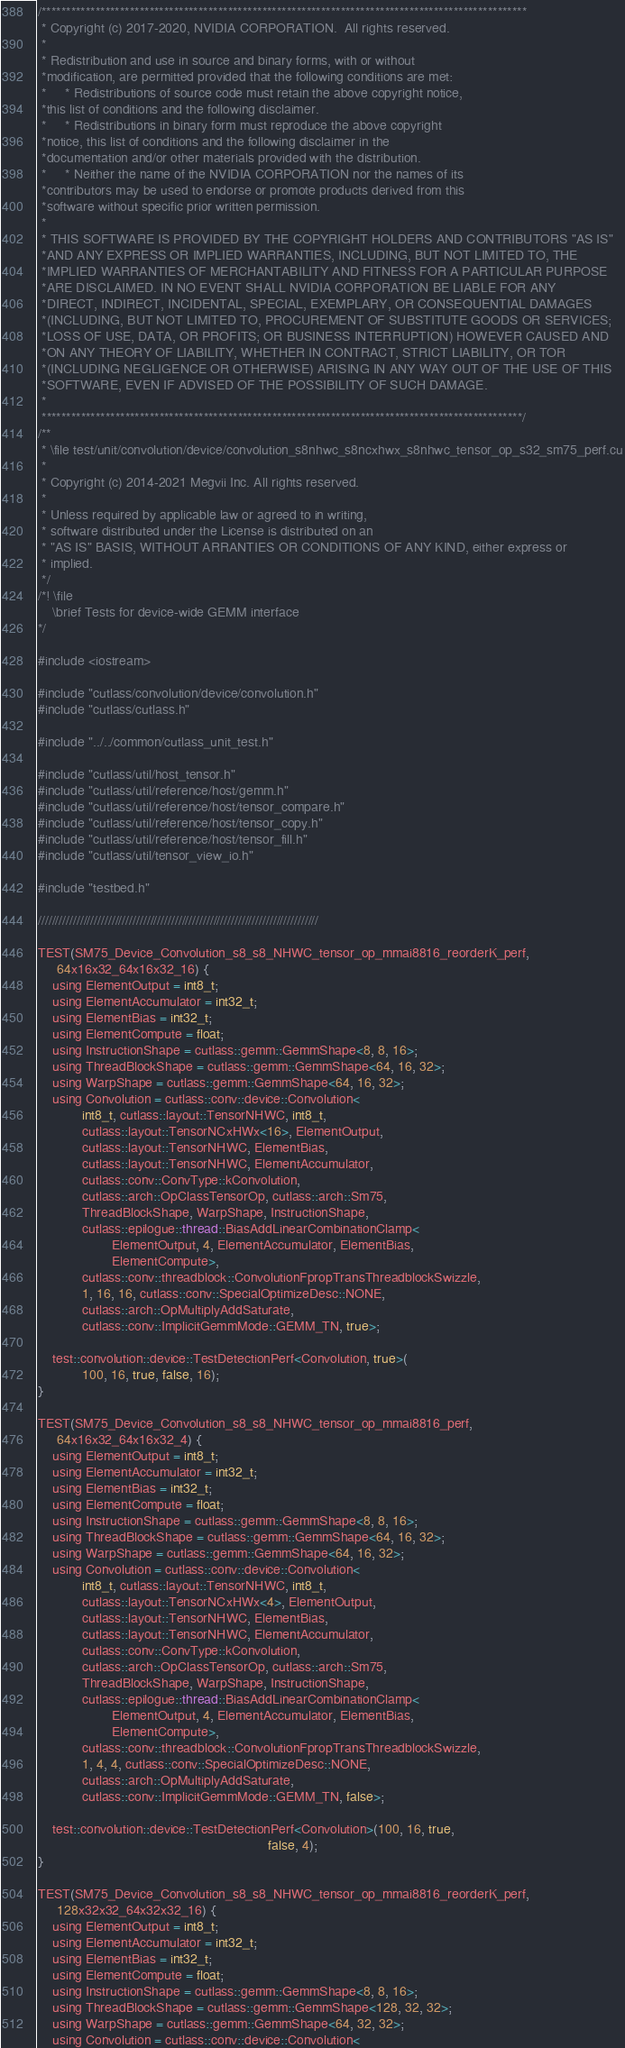Convert code to text. <code><loc_0><loc_0><loc_500><loc_500><_Cuda_>/***************************************************************************************************
 * Copyright (c) 2017-2020, NVIDIA CORPORATION.  All rights reserved.
 *
 * Redistribution and use in source and binary forms, with or without
 *modification, are permitted provided that the following conditions are met:
 *     * Redistributions of source code must retain the above copyright notice,
 *this list of conditions and the following disclaimer.
 *     * Redistributions in binary form must reproduce the above copyright
 *notice, this list of conditions and the following disclaimer in the
 *documentation and/or other materials provided with the distribution.
 *     * Neither the name of the NVIDIA CORPORATION nor the names of its
 *contributors may be used to endorse or promote products derived from this
 *software without specific prior written permission.
 *
 * THIS SOFTWARE IS PROVIDED BY THE COPYRIGHT HOLDERS AND CONTRIBUTORS "AS IS"
 *AND ANY EXPRESS OR IMPLIED WARRANTIES, INCLUDING, BUT NOT LIMITED TO, THE
 *IMPLIED WARRANTIES OF MERCHANTABILITY AND FITNESS FOR A PARTICULAR PURPOSE
 *ARE DISCLAIMED. IN NO EVENT SHALL NVIDIA CORPORATION BE LIABLE FOR ANY
 *DIRECT, INDIRECT, INCIDENTAL, SPECIAL, EXEMPLARY, OR CONSEQUENTIAL DAMAGES
 *(INCLUDING, BUT NOT LIMITED TO, PROCUREMENT OF SUBSTITUTE GOODS OR SERVICES;
 *LOSS OF USE, DATA, OR PROFITS; OR BUSINESS INTERRUPTION) HOWEVER CAUSED AND
 *ON ANY THEORY OF LIABILITY, WHETHER IN CONTRACT, STRICT LIABILITY, OR TOR
 *(INCLUDING NEGLIGENCE OR OTHERWISE) ARISING IN ANY WAY OUT OF THE USE OF THIS
 *SOFTWARE, EVEN IF ADVISED OF THE POSSIBILITY OF SUCH DAMAGE.
 *
 **************************************************************************************************/
/**
 * \file test/unit/convolution/device/convolution_s8nhwc_s8ncxhwx_s8nhwc_tensor_op_s32_sm75_perf.cu
 *
 * Copyright (c) 2014-2021 Megvii Inc. All rights reserved.
 *
 * Unless required by applicable law or agreed to in writing,
 * software distributed under the License is distributed on an
 * "AS IS" BASIS, WITHOUT ARRANTIES OR CONDITIONS OF ANY KIND, either express or
 * implied.
 */
/*! \file
    \brief Tests for device-wide GEMM interface
*/

#include <iostream>

#include "cutlass/convolution/device/convolution.h"
#include "cutlass/cutlass.h"

#include "../../common/cutlass_unit_test.h"

#include "cutlass/util/host_tensor.h"
#include "cutlass/util/reference/host/gemm.h"
#include "cutlass/util/reference/host/tensor_compare.h"
#include "cutlass/util/reference/host/tensor_copy.h"
#include "cutlass/util/reference/host/tensor_fill.h"
#include "cutlass/util/tensor_view_io.h"

#include "testbed.h"

////////////////////////////////////////////////////////////////////////////////

TEST(SM75_Device_Convolution_s8_s8_NHWC_tensor_op_mmai8816_reorderK_perf,
     64x16x32_64x16x32_16) {
    using ElementOutput = int8_t;
    using ElementAccumulator = int32_t;
    using ElementBias = int32_t;
    using ElementCompute = float;
    using InstructionShape = cutlass::gemm::GemmShape<8, 8, 16>;
    using ThreadBlockShape = cutlass::gemm::GemmShape<64, 16, 32>;
    using WarpShape = cutlass::gemm::GemmShape<64, 16, 32>;
    using Convolution = cutlass::conv::device::Convolution<
            int8_t, cutlass::layout::TensorNHWC, int8_t,
            cutlass::layout::TensorNCxHWx<16>, ElementOutput,
            cutlass::layout::TensorNHWC, ElementBias,
            cutlass::layout::TensorNHWC, ElementAccumulator,
            cutlass::conv::ConvType::kConvolution,
            cutlass::arch::OpClassTensorOp, cutlass::arch::Sm75,
            ThreadBlockShape, WarpShape, InstructionShape,
            cutlass::epilogue::thread::BiasAddLinearCombinationClamp<
                    ElementOutput, 4, ElementAccumulator, ElementBias,
                    ElementCompute>,
            cutlass::conv::threadblock::ConvolutionFpropTransThreadblockSwizzle,
            1, 16, 16, cutlass::conv::SpecialOptimizeDesc::NONE,
            cutlass::arch::OpMultiplyAddSaturate,
            cutlass::conv::ImplicitGemmMode::GEMM_TN, true>;

    test::convolution::device::TestDetectionPerf<Convolution, true>(
            100, 16, true, false, 16);
}

TEST(SM75_Device_Convolution_s8_s8_NHWC_tensor_op_mmai8816_perf,
     64x16x32_64x16x32_4) {
    using ElementOutput = int8_t;
    using ElementAccumulator = int32_t;
    using ElementBias = int32_t;
    using ElementCompute = float;
    using InstructionShape = cutlass::gemm::GemmShape<8, 8, 16>;
    using ThreadBlockShape = cutlass::gemm::GemmShape<64, 16, 32>;
    using WarpShape = cutlass::gemm::GemmShape<64, 16, 32>;
    using Convolution = cutlass::conv::device::Convolution<
            int8_t, cutlass::layout::TensorNHWC, int8_t,
            cutlass::layout::TensorNCxHWx<4>, ElementOutput,
            cutlass::layout::TensorNHWC, ElementBias,
            cutlass::layout::TensorNHWC, ElementAccumulator,
            cutlass::conv::ConvType::kConvolution,
            cutlass::arch::OpClassTensorOp, cutlass::arch::Sm75,
            ThreadBlockShape, WarpShape, InstructionShape,
            cutlass::epilogue::thread::BiasAddLinearCombinationClamp<
                    ElementOutput, 4, ElementAccumulator, ElementBias,
                    ElementCompute>,
            cutlass::conv::threadblock::ConvolutionFpropTransThreadblockSwizzle,
            1, 4, 4, cutlass::conv::SpecialOptimizeDesc::NONE,
            cutlass::arch::OpMultiplyAddSaturate,
            cutlass::conv::ImplicitGemmMode::GEMM_TN, false>;

    test::convolution::device::TestDetectionPerf<Convolution>(100, 16, true,
                                                              false, 4);
}

TEST(SM75_Device_Convolution_s8_s8_NHWC_tensor_op_mmai8816_reorderK_perf,
     128x32x32_64x32x32_16) {
    using ElementOutput = int8_t;
    using ElementAccumulator = int32_t;
    using ElementBias = int32_t;
    using ElementCompute = float;
    using InstructionShape = cutlass::gemm::GemmShape<8, 8, 16>;
    using ThreadBlockShape = cutlass::gemm::GemmShape<128, 32, 32>;
    using WarpShape = cutlass::gemm::GemmShape<64, 32, 32>;
    using Convolution = cutlass::conv::device::Convolution<</code> 